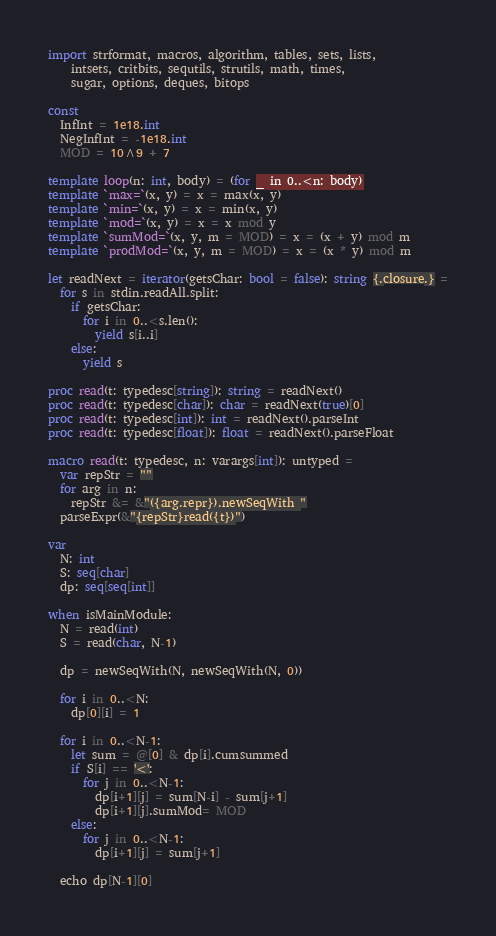Convert code to text. <code><loc_0><loc_0><loc_500><loc_500><_Nim_>import strformat, macros, algorithm, tables, sets, lists,
    intsets, critbits, sequtils, strutils, math, times,
    sugar, options, deques, bitops

const
  InfInt = 1e18.int
  NegInfInt = -1e18.int
  MOD = 10^9 + 7

template loop(n: int, body) = (for _ in 0..<n: body)
template `max=`(x, y) = x = max(x, y)
template `min=`(x, y) = x = min(x, y)
template `mod=`(x, y) = x = x mod y
template `sumMod=`(x, y, m = MOD) = x = (x + y) mod m
template `prodMod=`(x, y, m = MOD) = x = (x * y) mod m

let readNext = iterator(getsChar: bool = false): string {.closure.} =
  for s in stdin.readAll.split:
    if getsChar:
      for i in 0..<s.len():
        yield s[i..i]
    else:
      yield s

proc read(t: typedesc[string]): string = readNext()
proc read(t: typedesc[char]): char = readNext(true)[0]
proc read(t: typedesc[int]): int = readNext().parseInt
proc read(t: typedesc[float]): float = readNext().parseFloat

macro read(t: typedesc, n: varargs[int]): untyped =
  var repStr = ""
  for arg in n:
    repStr &= &"({arg.repr}).newSeqWith "
  parseExpr(&"{repStr}read({t})")

var
  N: int
  S: seq[char]
  dp: seq[seq[int]]

when isMainModule:
  N = read(int)
  S = read(char, N-1)

  dp = newSeqWith(N, newSeqWith(N, 0))

  for i in 0..<N:
    dp[0][i] = 1

  for i in 0..<N-1:
    let sum = @[0] & dp[i].cumsummed
    if S[i] == '<':
      for j in 0..<N-1:
        dp[i+1][j] = sum[N-i] - sum[j+1]
        dp[i+1][j].sumMod= MOD
    else:
      for j in 0..<N-1:
        dp[i+1][j] = sum[j+1]

  echo dp[N-1][0]
</code> 